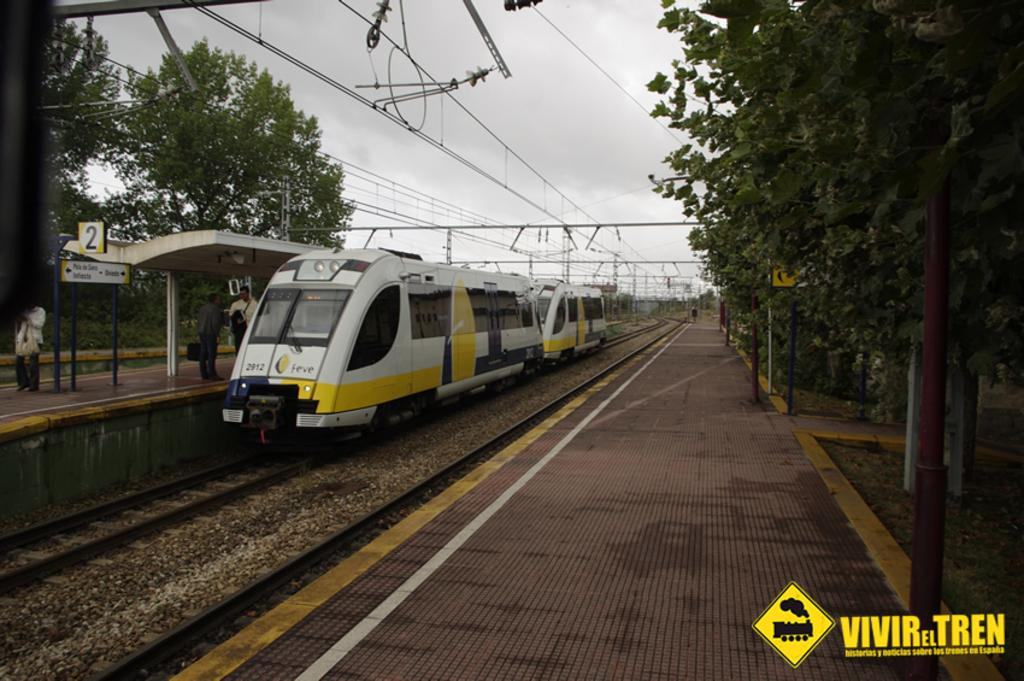<image>
Render a clear and concise summary of the photo. An image of a train is marked with the word VIVRelTREN. 